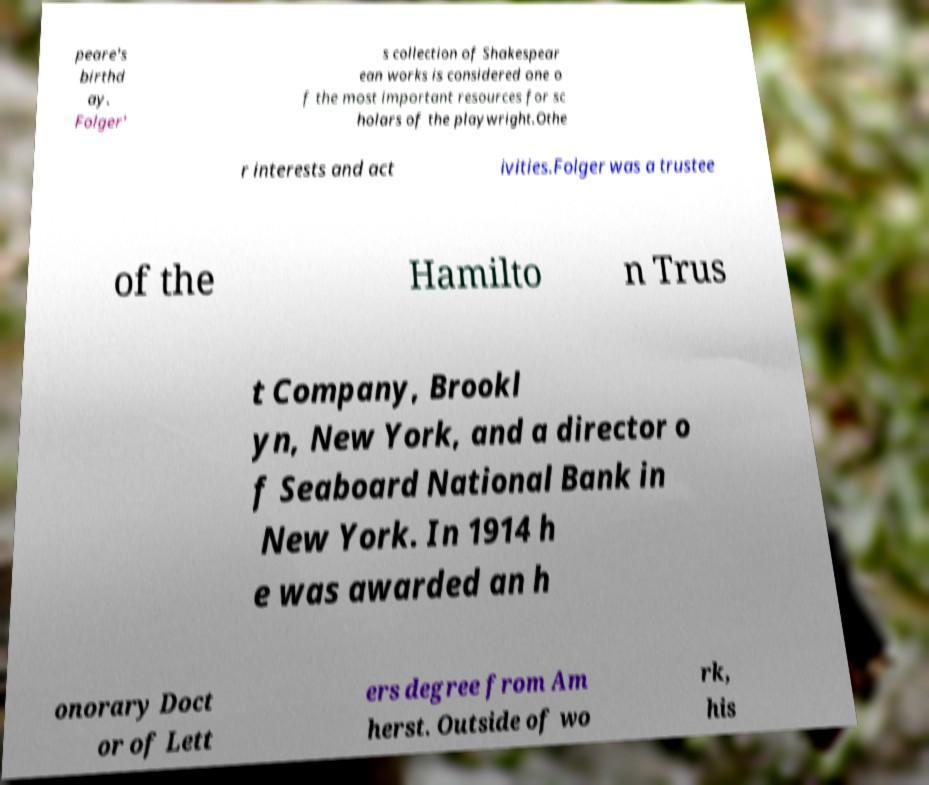I need the written content from this picture converted into text. Can you do that? peare's birthd ay. Folger' s collection of Shakespear ean works is considered one o f the most important resources for sc holars of the playwright.Othe r interests and act ivities.Folger was a trustee of the Hamilto n Trus t Company, Brookl yn, New York, and a director o f Seaboard National Bank in New York. In 1914 h e was awarded an h onorary Doct or of Lett ers degree from Am herst. Outside of wo rk, his 